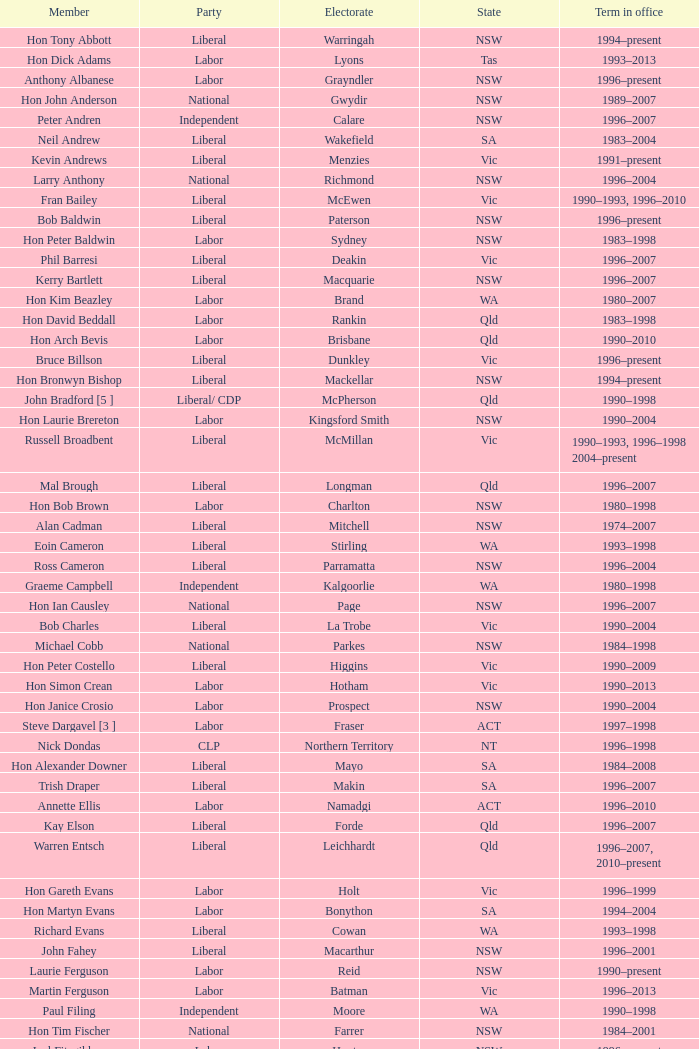What state was hon david beddall associated with? Qld. 